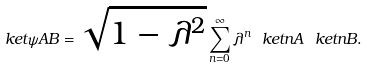Convert formula to latex. <formula><loc_0><loc_0><loc_500><loc_500>\ k e t { \psi } { A B } = \sqrt { 1 - \lambda ^ { 2 } } \sum _ { n = 0 } ^ { \infty } \lambda ^ { n } \ k e t { n } { A } \ k e t { n } { B } .</formula> 